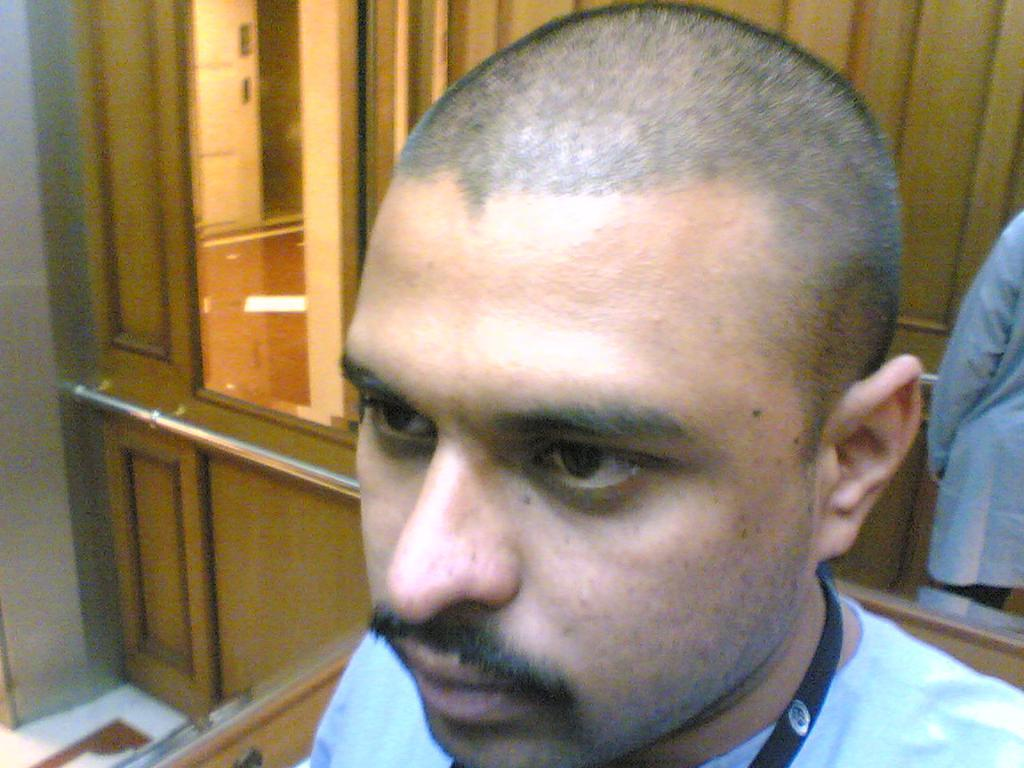What is present in the image? There is a man and a mirror in the image. What is the mirror reflecting in the image? The mirror reflects cupboards in the image. What type of tin can be seen in the image? There is no tin present in the image. Is there a fire visible in the image? There is no fire visible in the image. What type of berry can be seen growing on the man's head in the image? There is no berry present on the man's head in the image. 